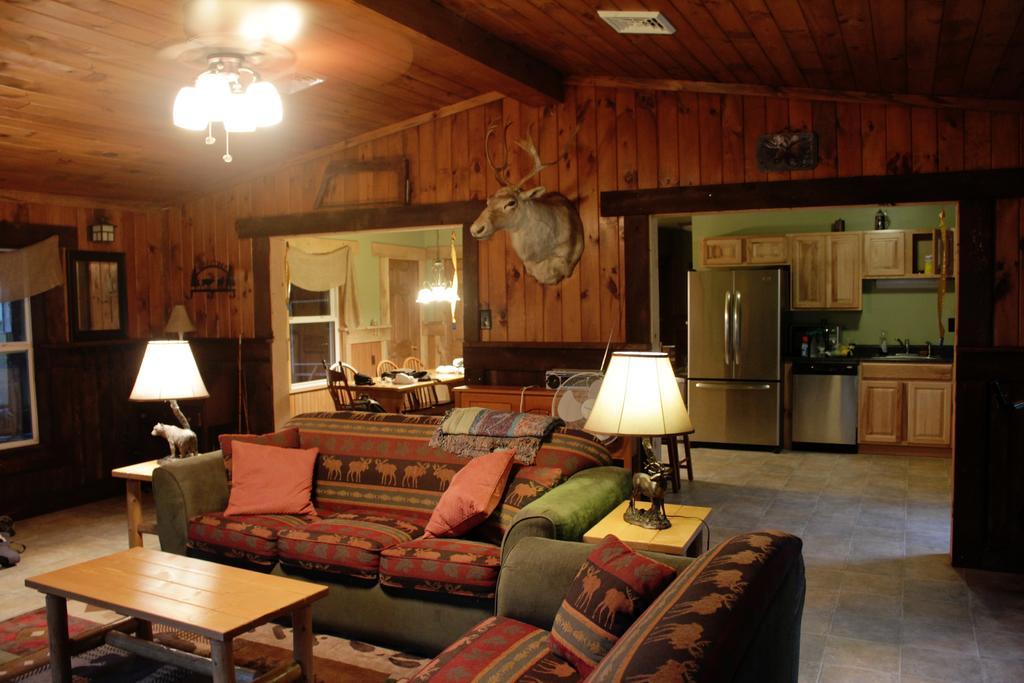Can you describe this image briefly? In this picture we can see the inside view of a room. This is sofa and these are the pillows. There is a table and these are the lamps. On the background we can see the wall. And this is sculpture. And there is a light. 